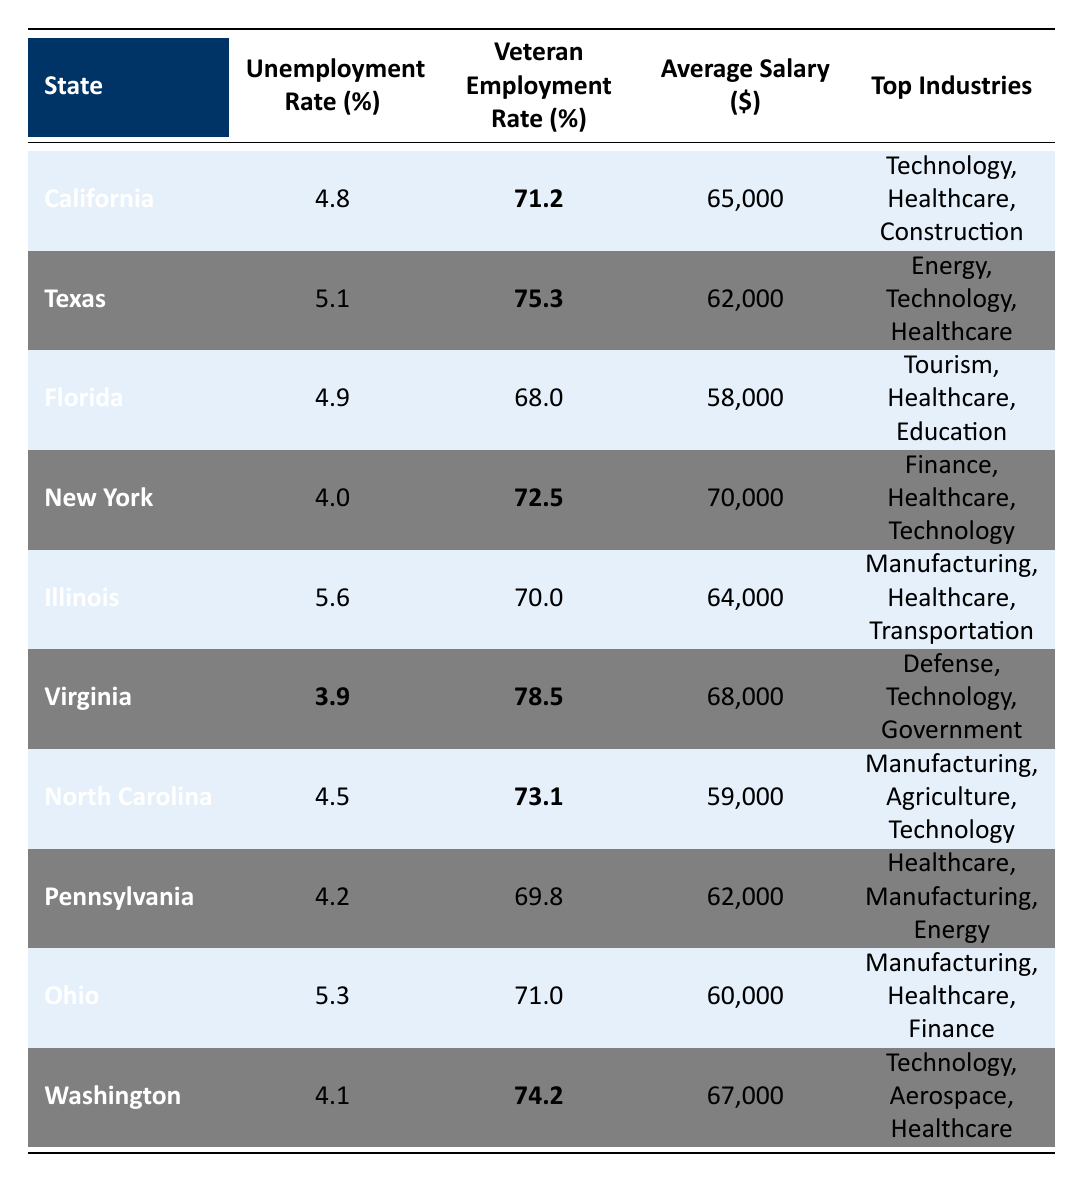What is the veteran employment rate in California? The table lists the veteran employment rate for California as bolded value 71.2%.
Answer: 71.2% Which state has the lowest unemployment rate? Virginia has the lowest unemployment rate at 3.9%, as indicated in the table.
Answer: 3.9% What is the average salary for veterans in New York? The table shows that the average salary for veterans in New York is $70,000.
Answer: $70,000 Which top industry is common in both Texas and California? The top industry common in both Texas and California is "Technology," as it appears in both states' lists of top industries.
Answer: Technology What is the difference in veteran employment rates between Texas and Florida? Texas has a veteran employment rate of 75.3% and Florida has 68.0%. The difference is 75.3 - 68.0 = 7.3%.
Answer: 7.3% Is the unemployment rate higher in Illinois than in Florida? The unemployment rate in Illinois is 5.6%, while in Florida it is 4.9%, indicating that Illinois does have a higher unemployment rate than Florida.
Answer: Yes What is the average veteran employment rate across the states listed? To calculate the average, we sum the veteran employment rates: 71.2 + 75.3 + 68.0 + 72.5 + 70.0 + 78.5 + 73.1 + 69.8 + 71.0 + 74.2 = 739.6 and divide by 10 states, resulting in 739.6 / 10 = 73.96%.
Answer: 73.96% Which state has both the highest veteran employment rate and the lowest unemployment rate? Virginia has the highest veteran employment rate at 78.5% and the lowest unemployment rate at 3.9%, making it the only state with both values.
Answer: Virginia How many states have a veteran employment rate over 72%? The states with veteran employment rates over 72% are Texas (75.3%), Virginia (78.5%), and Washington (74.2%). Thus, there are three states that meet this criterion.
Answer: 3 Is the average salary for veterans in Virginia higher than in North Carolina? Virginia has an average salary of $68,000 and North Carolina has $59,000; therefore, Virginia's average salary is higher than North Carolina's.
Answer: Yes What is the total of average salaries for veterans in all listed states? Adding the average salaries: 65000 + 62000 + 58000 + 70000 + 64000 + 68000 + 59000 + 62000 + 60000 + 67000 =  682000.
Answer: 682000 